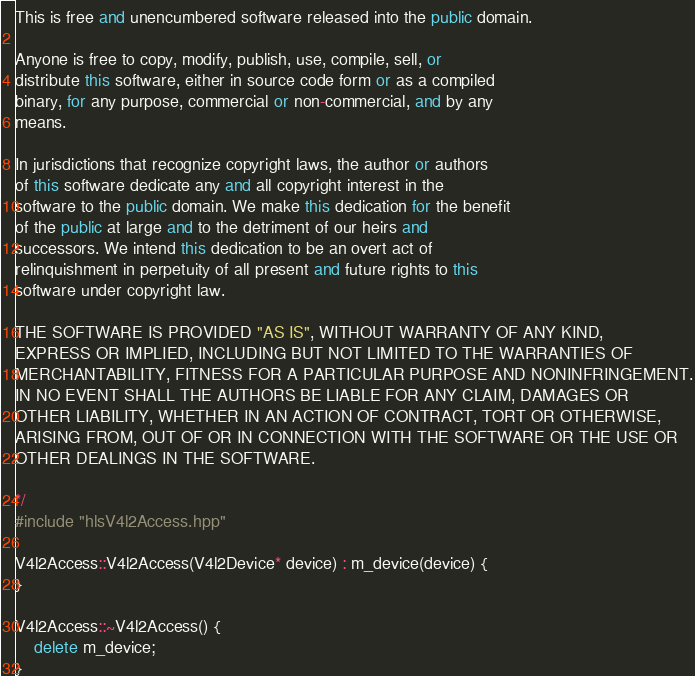Convert code to text. <code><loc_0><loc_0><loc_500><loc_500><_C++_>
This is free and unencumbered software released into the public domain.

Anyone is free to copy, modify, publish, use, compile, sell, or
distribute this software, either in source code form or as a compiled
binary, for any purpose, commercial or non-commercial, and by any
means.

In jurisdictions that recognize copyright laws, the author or authors
of this software dedicate any and all copyright interest in the
software to the public domain. We make this dedication for the benefit
of the public at large and to the detriment of our heirs and
successors. We intend this dedication to be an overt act of
relinquishment in perpetuity of all present and future rights to this
software under copyright law.

THE SOFTWARE IS PROVIDED "AS IS", WITHOUT WARRANTY OF ANY KIND,
EXPRESS OR IMPLIED, INCLUDING BUT NOT LIMITED TO THE WARRANTIES OF
MERCHANTABILITY, FITNESS FOR A PARTICULAR PURPOSE AND NONINFRINGEMENT.
IN NO EVENT SHALL THE AUTHORS BE LIABLE FOR ANY CLAIM, DAMAGES OR
OTHER LIABILITY, WHETHER IN AN ACTION OF CONTRACT, TORT OR OTHERWISE,
ARISING FROM, OUT OF OR IN CONNECTION WITH THE SOFTWARE OR THE USE OR
OTHER DEALINGS IN THE SOFTWARE.

*/
#include "hlsV4l2Access.hpp"

V4l2Access::V4l2Access(V4l2Device* device) : m_device(device) {
}

V4l2Access::~V4l2Access() { 
	delete m_device; 
}
</code> 